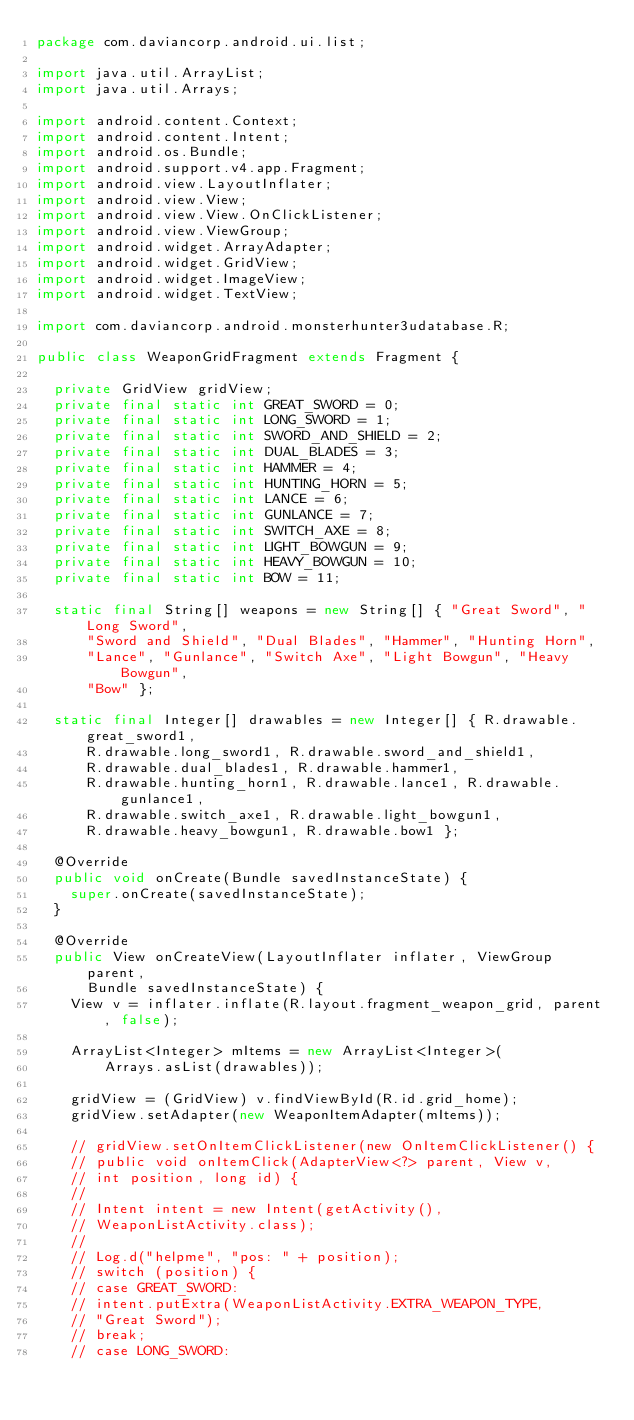<code> <loc_0><loc_0><loc_500><loc_500><_Java_>package com.daviancorp.android.ui.list;

import java.util.ArrayList;
import java.util.Arrays;

import android.content.Context;
import android.content.Intent;
import android.os.Bundle;
import android.support.v4.app.Fragment;
import android.view.LayoutInflater;
import android.view.View;
import android.view.View.OnClickListener;
import android.view.ViewGroup;
import android.widget.ArrayAdapter;
import android.widget.GridView;
import android.widget.ImageView;
import android.widget.TextView;

import com.daviancorp.android.monsterhunter3udatabase.R;

public class WeaponGridFragment extends Fragment {

	private GridView gridView;
	private final static int GREAT_SWORD = 0;
	private final static int LONG_SWORD = 1;
	private final static int SWORD_AND_SHIELD = 2;
	private final static int DUAL_BLADES = 3;
	private final static int HAMMER = 4;
	private final static int HUNTING_HORN = 5;
	private final static int LANCE = 6;
	private final static int GUNLANCE = 7;
	private final static int SWITCH_AXE = 8;
	private final static int LIGHT_BOWGUN = 9;
	private final static int HEAVY_BOWGUN = 10;
	private final static int BOW = 11;

	static final String[] weapons = new String[] { "Great Sword", "Long Sword",
			"Sword and Shield", "Dual Blades", "Hammer", "Hunting Horn",
			"Lance", "Gunlance", "Switch Axe", "Light Bowgun", "Heavy Bowgun",
			"Bow" };

	static final Integer[] drawables = new Integer[] { R.drawable.great_sword1,
			R.drawable.long_sword1, R.drawable.sword_and_shield1,
			R.drawable.dual_blades1, R.drawable.hammer1,
			R.drawable.hunting_horn1, R.drawable.lance1, R.drawable.gunlance1,
			R.drawable.switch_axe1, R.drawable.light_bowgun1,
			R.drawable.heavy_bowgun1, R.drawable.bow1 };

	@Override
	public void onCreate(Bundle savedInstanceState) {
		super.onCreate(savedInstanceState);
	}

	@Override
	public View onCreateView(LayoutInflater inflater, ViewGroup parent,
			Bundle savedInstanceState) {
		View v = inflater.inflate(R.layout.fragment_weapon_grid, parent, false);

		ArrayList<Integer> mItems = new ArrayList<Integer>(
				Arrays.asList(drawables));

		gridView = (GridView) v.findViewById(R.id.grid_home);
		gridView.setAdapter(new WeaponItemAdapter(mItems));

		// gridView.setOnItemClickListener(new OnItemClickListener() {
		// public void onItemClick(AdapterView<?> parent, View v,
		// int position, long id) {
		//
		// Intent intent = new Intent(getActivity(),
		// WeaponListActivity.class);
		//
		// Log.d("helpme", "pos: " + position);
		// switch (position) {
		// case GREAT_SWORD:
		// intent.putExtra(WeaponListActivity.EXTRA_WEAPON_TYPE,
		// "Great Sword");
		// break;
		// case LONG_SWORD:</code> 